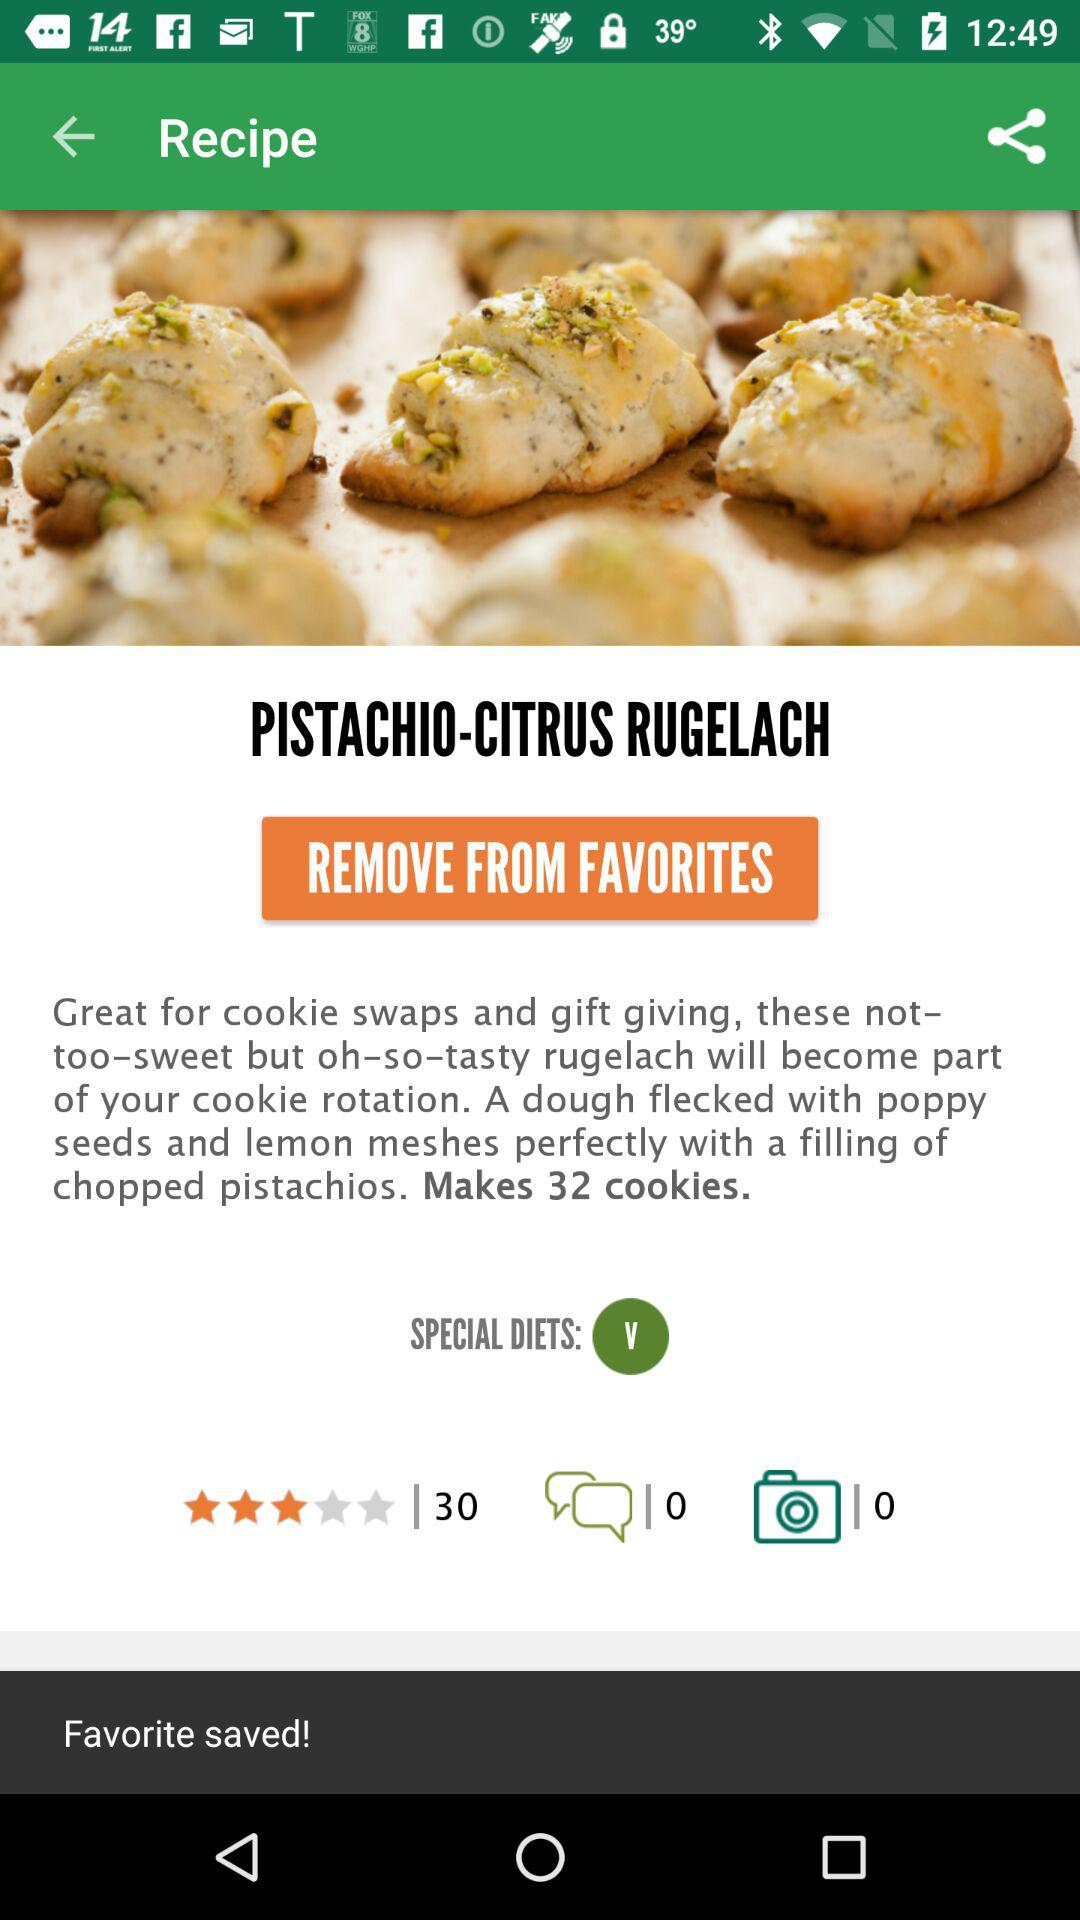How many people have given a rating to the recipe? The rating was given by 30 people. 